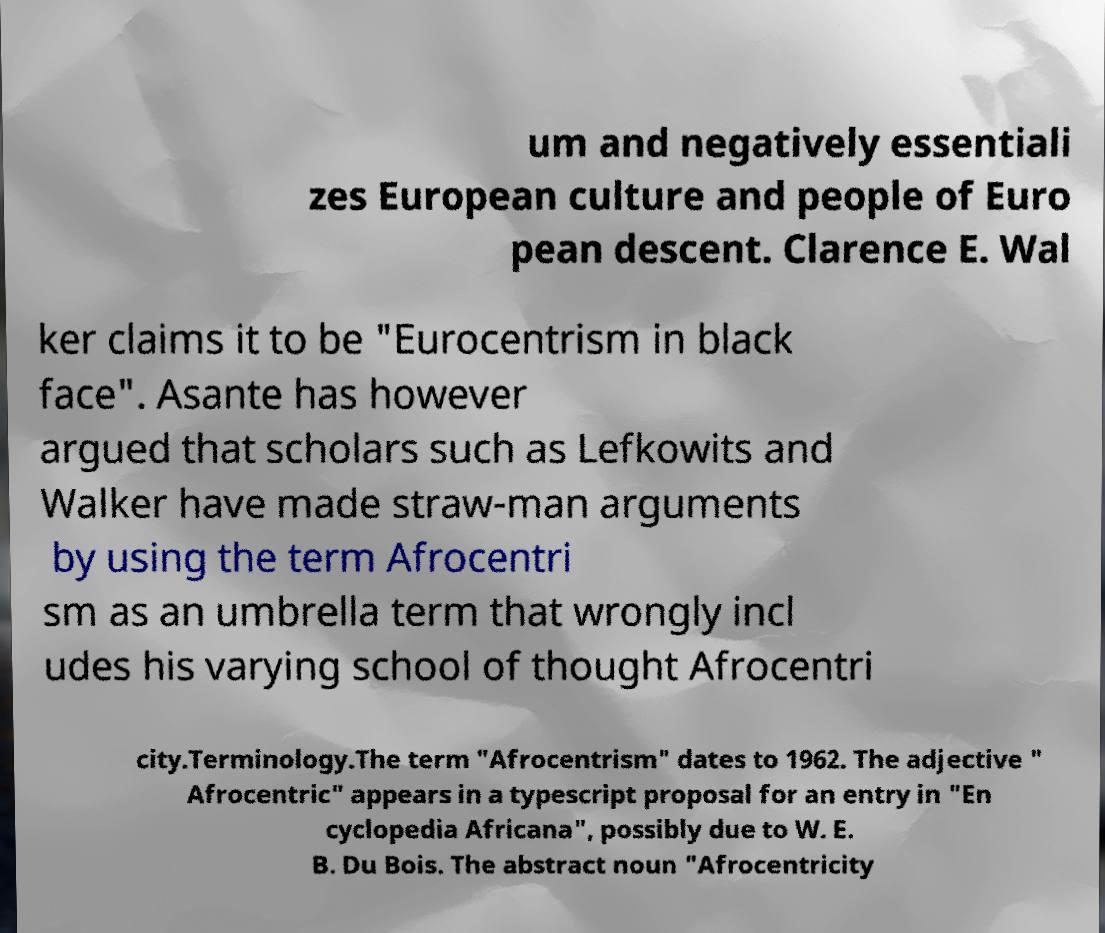Can you accurately transcribe the text from the provided image for me? um and negatively essentiali zes European culture and people of Euro pean descent. Clarence E. Wal ker claims it to be "Eurocentrism in black face". Asante has however argued that scholars such as Lefkowits and Walker have made straw-man arguments by using the term Afrocentri sm as an umbrella term that wrongly incl udes his varying school of thought Afrocentri city.Terminology.The term "Afrocentrism" dates to 1962. The adjective " Afrocentric" appears in a typescript proposal for an entry in "En cyclopedia Africana", possibly due to W. E. B. Du Bois. The abstract noun "Afrocentricity 